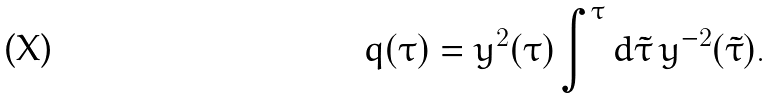<formula> <loc_0><loc_0><loc_500><loc_500>q ( \tau ) = y ^ { 2 } ( \tau ) \int ^ { \tau } d \tilde { \tau } \, y ^ { - 2 } ( \tilde { \tau } ) .</formula> 